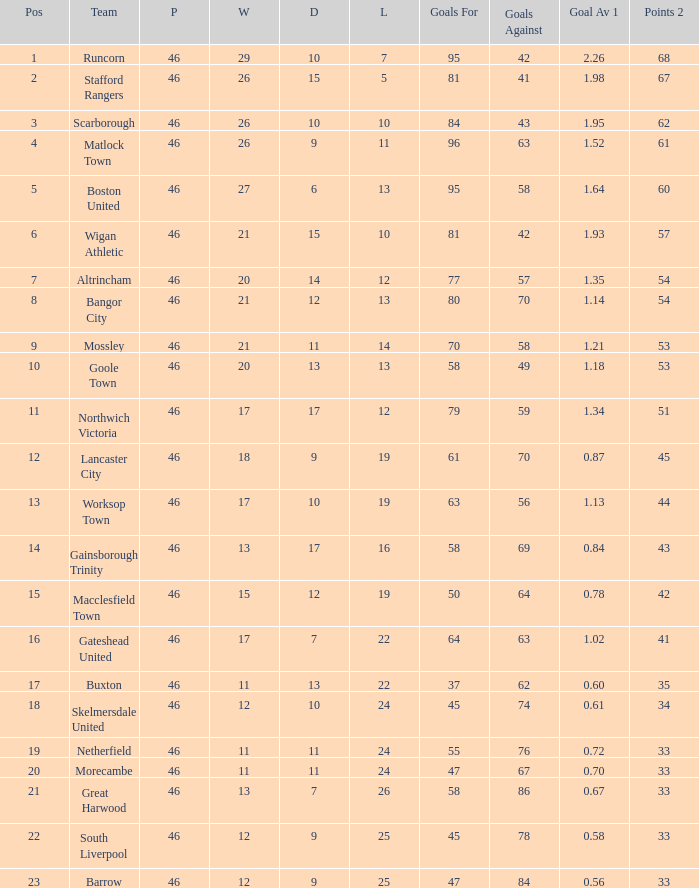34? Northwich Victoria. 